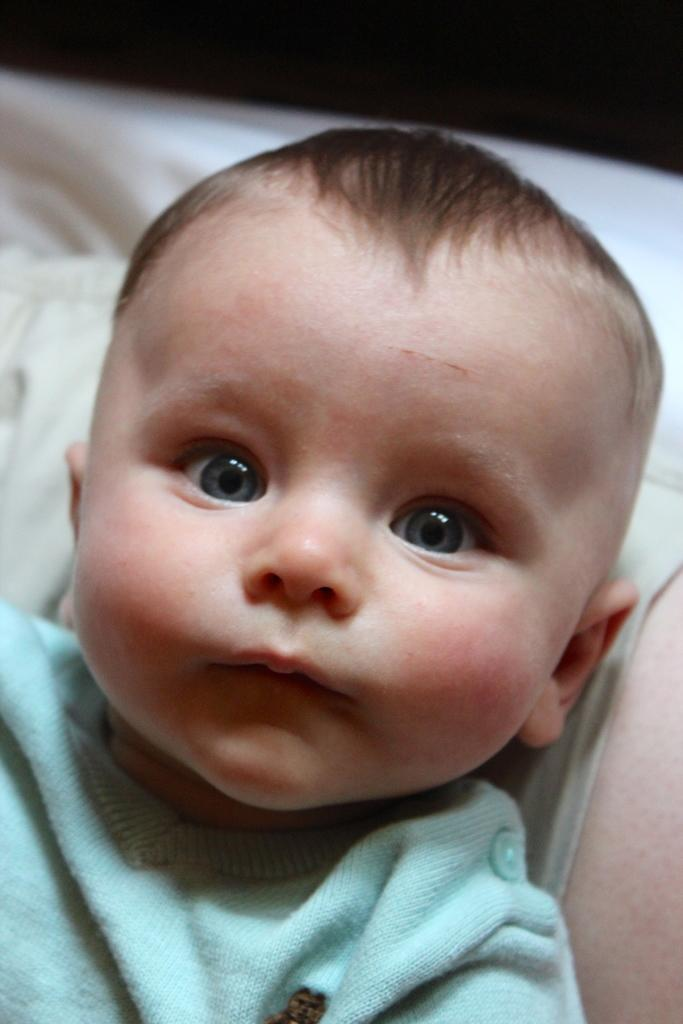What is the main subject of the image? There is a baby boy in the image. What is the baby boy doing in the image? The baby boy is laying down. What object is present in the image that might provide comfort or support? There is a pillow in the image. How would you describe the background of the image? The background of the image appears blurry. What type of industry can be seen in the background of the image? There is no industry visible in the image; the background appears blurry. Are there any fairies or toads present in the image? There are no fairies or toads present in the image; it features a baby boy laying down with a pillow. 